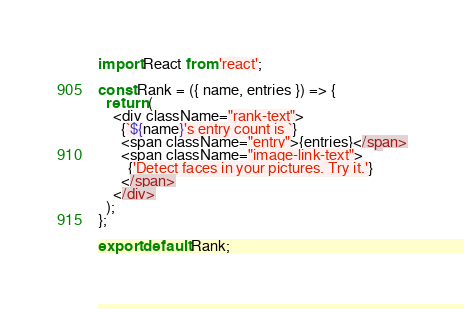Convert code to text. <code><loc_0><loc_0><loc_500><loc_500><_JavaScript_>import React from 'react';

const Rank = ({ name, entries }) => {
  return (
    <div className="rank-text">
      {`${name}'s entry count is `}
      <span className="entry">{entries}</span>
      <span className="image-link-text">
        {'Detect faces in your pictures. Try it.'}
      </span>
    </div>
  );
};

export default Rank;
</code> 